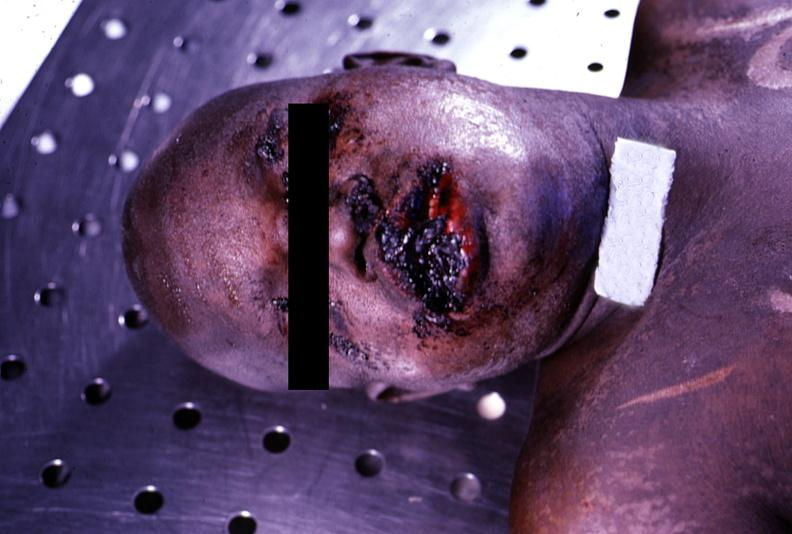does granulomata slide show ulcerations, herpes simplex?
Answer the question using a single word or phrase. No 